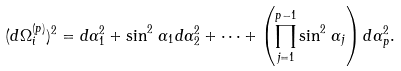<formula> <loc_0><loc_0><loc_500><loc_500>( d \Omega _ { i } ^ { ( p ) } ) ^ { 2 } = d \alpha _ { 1 } ^ { 2 } + \sin ^ { 2 } \, \alpha _ { 1 } d \alpha _ { 2 } ^ { 2 } + \cdots + \left ( \prod _ { j = 1 } ^ { p - 1 } \sin ^ { 2 } \, \alpha _ { j } \right ) d \alpha _ { p } ^ { 2 } .</formula> 